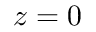Convert formula to latex. <formula><loc_0><loc_0><loc_500><loc_500>z = 0</formula> 